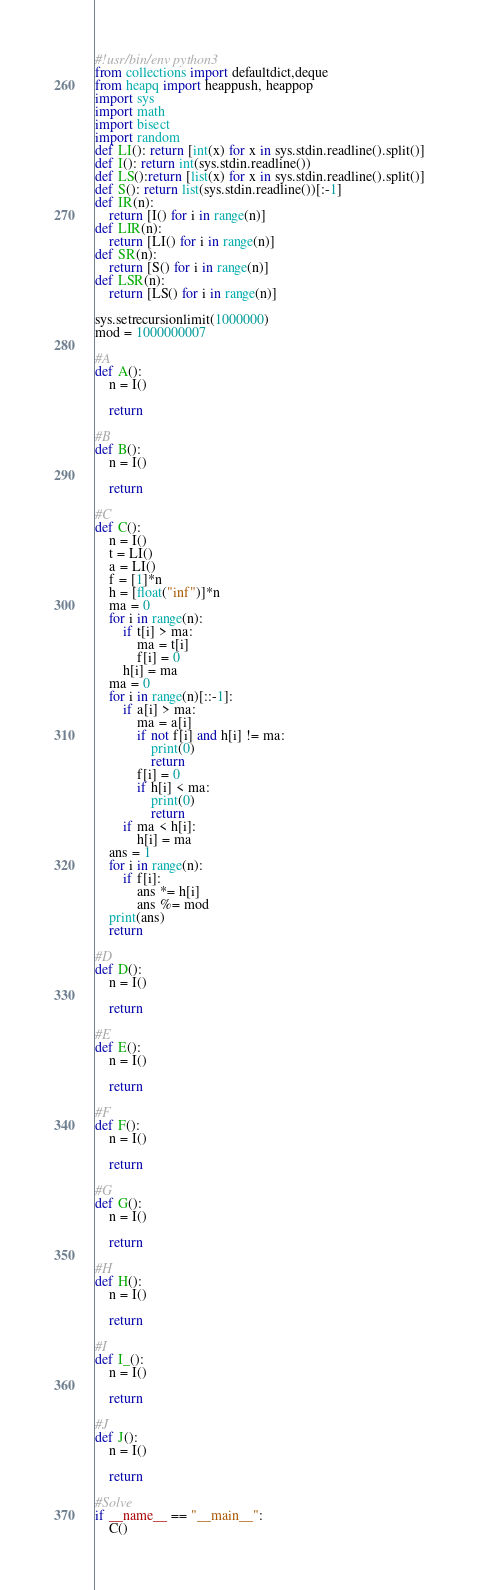<code> <loc_0><loc_0><loc_500><loc_500><_Python_>#!usr/bin/env python3
from collections import defaultdict,deque
from heapq import heappush, heappop
import sys
import math
import bisect
import random
def LI(): return [int(x) for x in sys.stdin.readline().split()]
def I(): return int(sys.stdin.readline())
def LS():return [list(x) for x in sys.stdin.readline().split()]
def S(): return list(sys.stdin.readline())[:-1]
def IR(n):
    return [I() for i in range(n)]
def LIR(n):
    return [LI() for i in range(n)]
def SR(n):
    return [S() for i in range(n)]
def LSR(n):
    return [LS() for i in range(n)]

sys.setrecursionlimit(1000000)
mod = 1000000007

#A
def A():
    n = I()

    return

#B
def B():
    n = I()

    return

#C
def C():
    n = I()
    t = LI()
    a = LI()
    f = [1]*n
    h = [float("inf")]*n
    ma = 0
    for i in range(n):
        if t[i] > ma:
            ma = t[i]
            f[i] = 0
        h[i] = ma
    ma = 0
    for i in range(n)[::-1]:
        if a[i] > ma:
            ma = a[i]
            if not f[i] and h[i] != ma:
                print(0)
                return
            f[i] = 0
            if h[i] < ma:
                print(0)
                return
        if ma < h[i]:
            h[i] = ma
    ans = 1
    for i in range(n):
        if f[i]:
            ans *= h[i]
            ans %= mod
    print(ans)
    return

#D
def D():
    n = I()

    return

#E
def E():
    n = I()

    return

#F
def F():
    n = I()

    return

#G
def G():
    n = I()

    return

#H
def H():
    n = I()

    return

#I
def I_():
    n = I()

    return

#J
def J():
    n = I()

    return

#Solve
if __name__ == "__main__":
    C()
</code> 